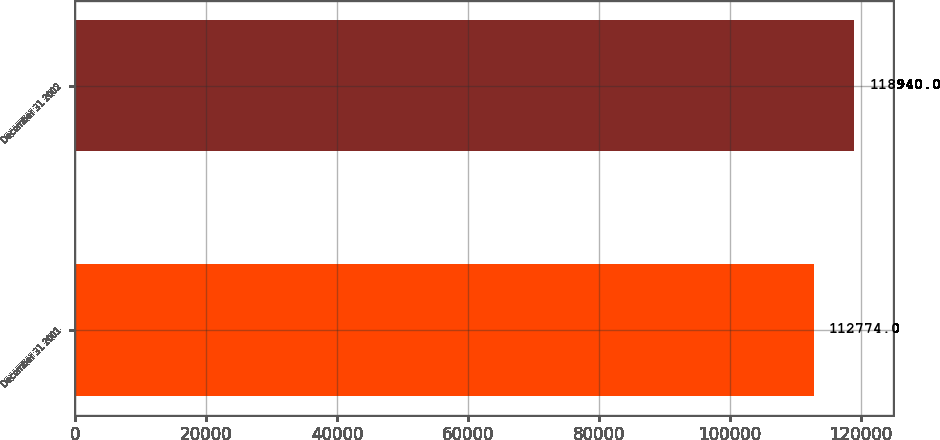<chart> <loc_0><loc_0><loc_500><loc_500><bar_chart><fcel>December 31 2001<fcel>December 31 2002<nl><fcel>112774<fcel>118940<nl></chart> 